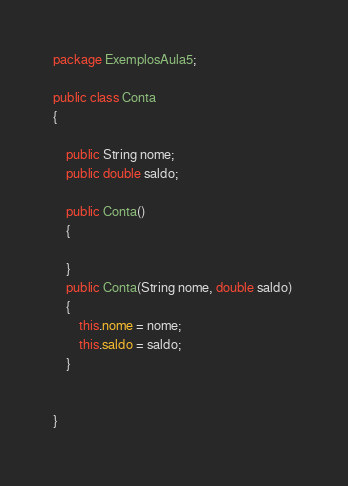<code> <loc_0><loc_0><loc_500><loc_500><_Java_>package ExemplosAula5;

public class Conta 
{

	public String nome;
	public double saldo;
	
	public Conta()
	{
		
	}
	public Conta(String nome, double saldo) 
	{
		this.nome = nome;
		this.saldo = saldo;
	}
	
	
}
</code> 